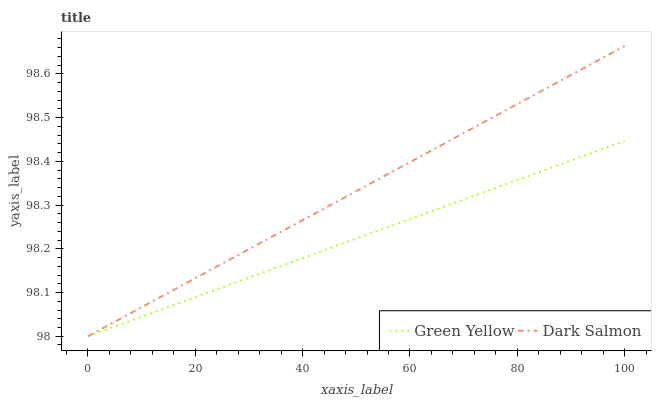Does Green Yellow have the minimum area under the curve?
Answer yes or no. Yes. Does Dark Salmon have the maximum area under the curve?
Answer yes or no. Yes. Does Dark Salmon have the minimum area under the curve?
Answer yes or no. No. Is Dark Salmon the smoothest?
Answer yes or no. Yes. Is Green Yellow the roughest?
Answer yes or no. Yes. Is Dark Salmon the roughest?
Answer yes or no. No. Does Green Yellow have the lowest value?
Answer yes or no. Yes. Does Dark Salmon have the highest value?
Answer yes or no. Yes. Does Dark Salmon intersect Green Yellow?
Answer yes or no. Yes. Is Dark Salmon less than Green Yellow?
Answer yes or no. No. Is Dark Salmon greater than Green Yellow?
Answer yes or no. No. 